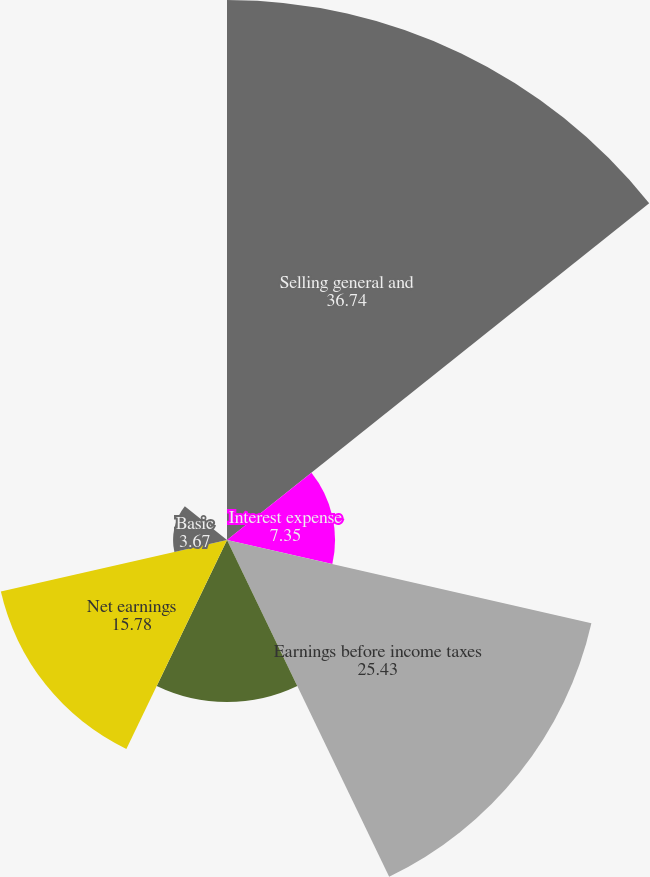Convert chart to OTSL. <chart><loc_0><loc_0><loc_500><loc_500><pie_chart><fcel>Selling general and<fcel>Interest expense<fcel>Earnings before income taxes<fcel>Income tax provision<fcel>Net earnings<fcel>Basic<fcel>Diluted<nl><fcel>36.74%<fcel>7.35%<fcel>25.43%<fcel>11.02%<fcel>15.78%<fcel>3.67%<fcel>0.0%<nl></chart> 